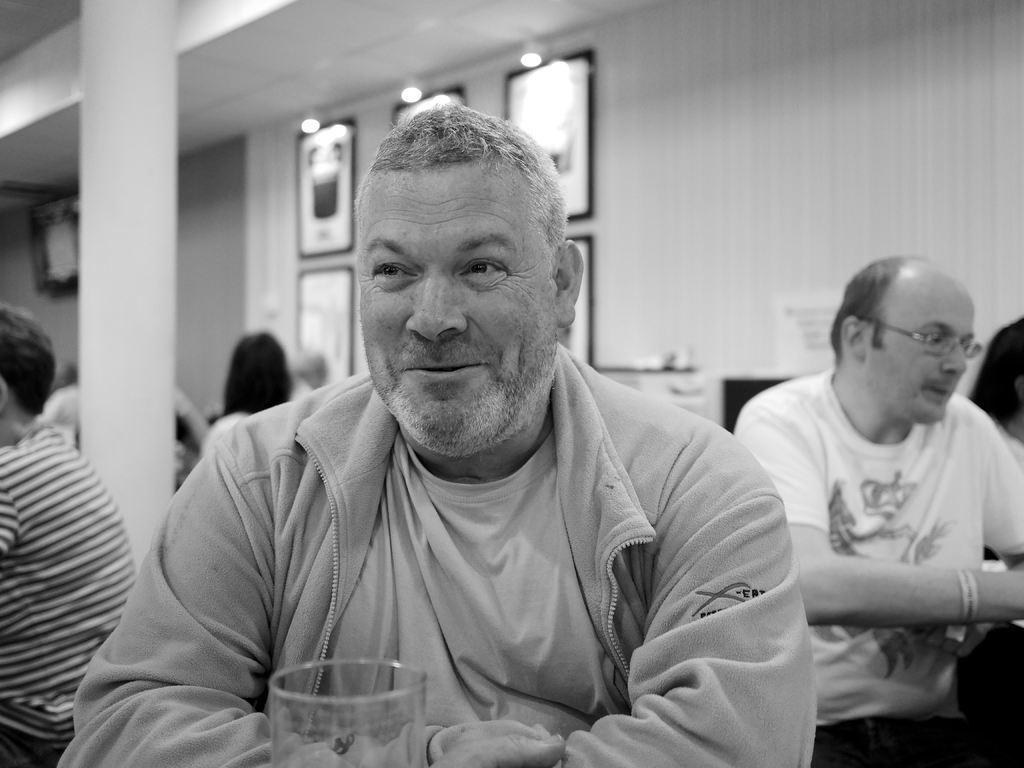Could you give a brief overview of what you see in this image? In this image there is a person sitting and smiling , there is a glass, group of people sitting, and in the background there are frames attached to the wall , lights. 